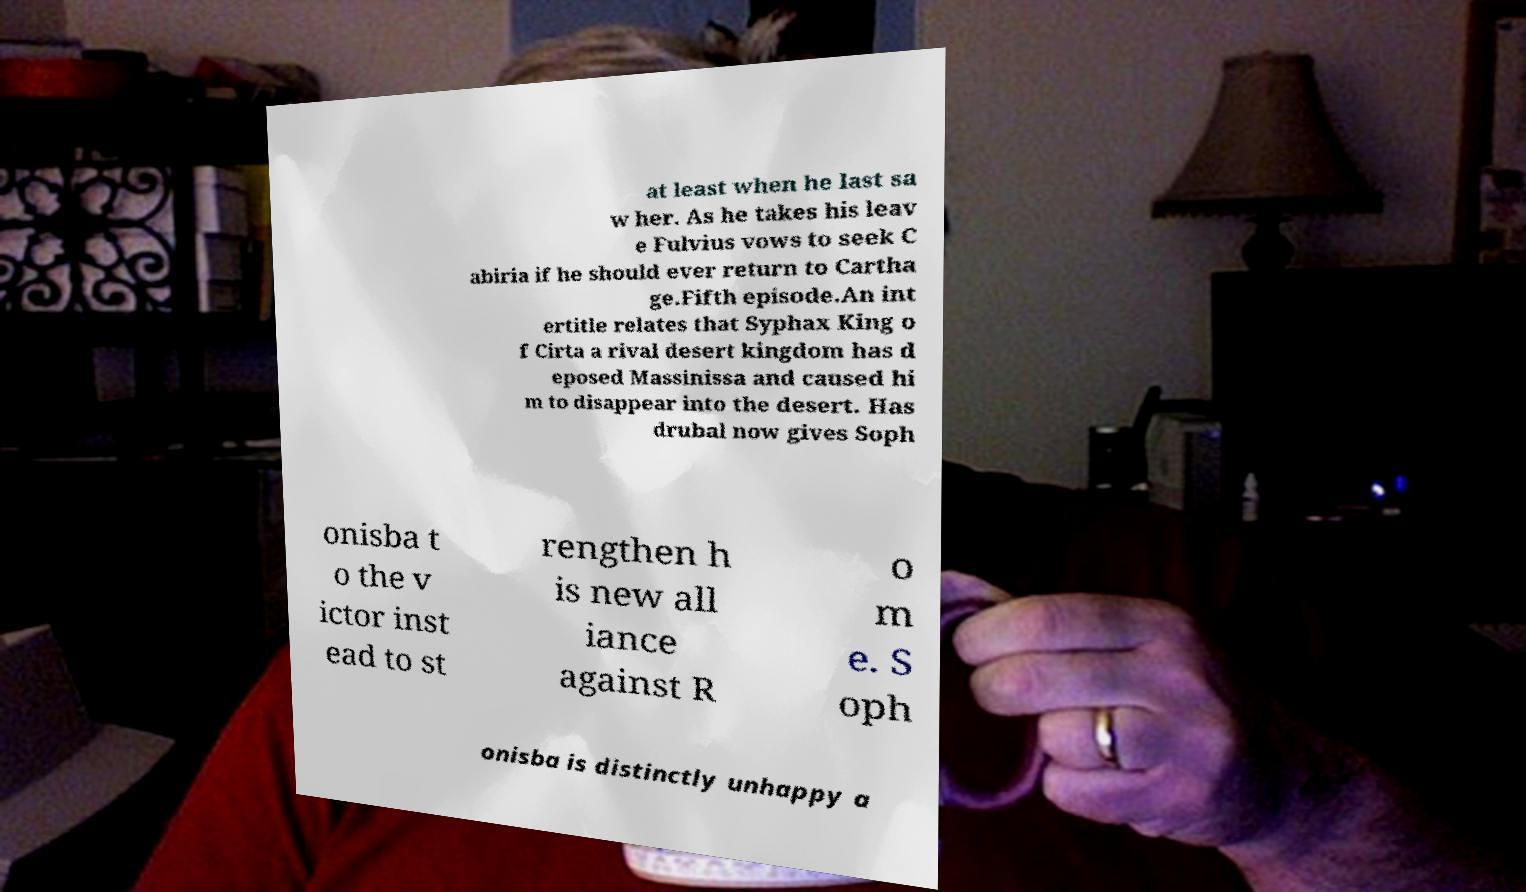Can you accurately transcribe the text from the provided image for me? at least when he last sa w her. As he takes his leav e Fulvius vows to seek C abiria if he should ever return to Cartha ge.Fifth episode.An int ertitle relates that Syphax King o f Cirta a rival desert kingdom has d eposed Massinissa and caused hi m to disappear into the desert. Has drubal now gives Soph onisba t o the v ictor inst ead to st rengthen h is new all iance against R o m e. S oph onisba is distinctly unhappy a 